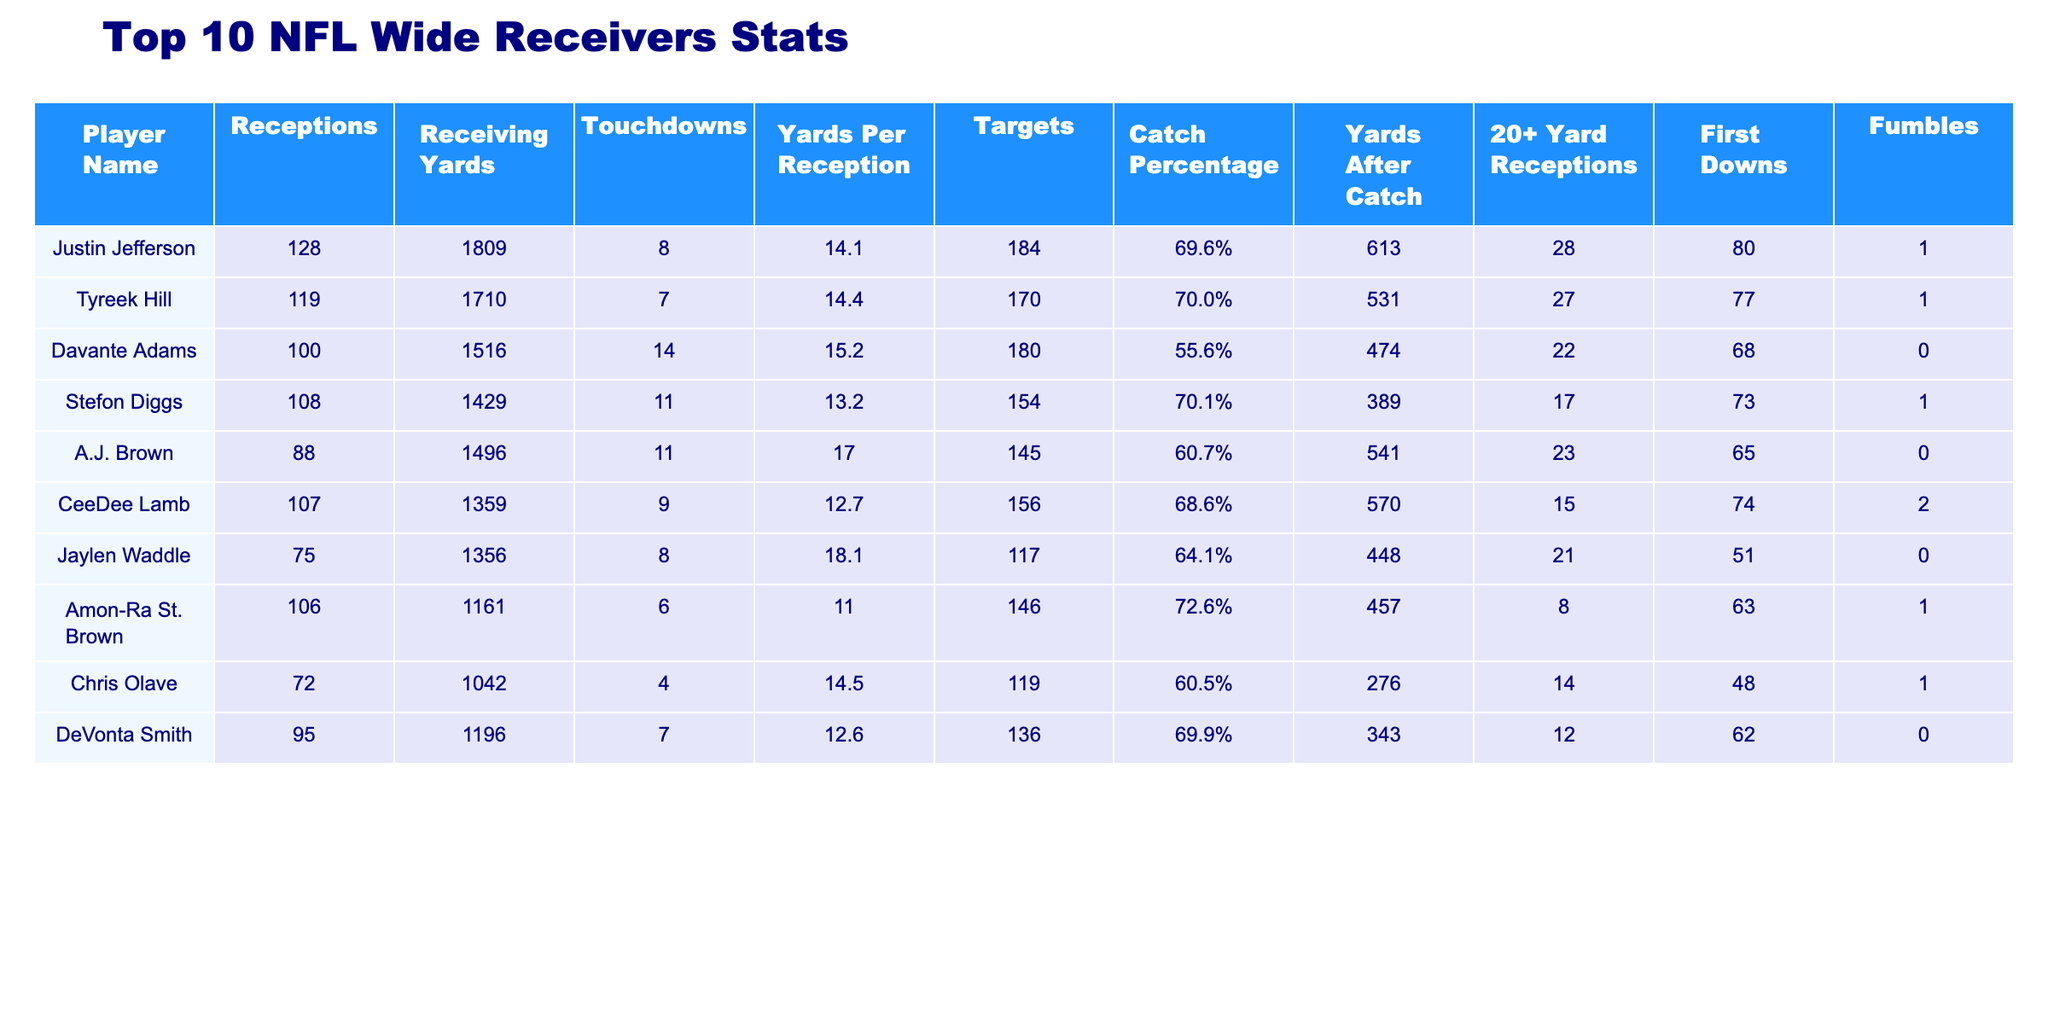What is the total number of touchdowns scored by all players in the table? To find the total number of touchdowns scored, sum the touchdowns of each player: 8 + 7 + 14 + 11 + 11 + 9 + 8 + 6 + 4 + 7 = 85.
Answer: 85 Which player has the highest receptions? Looking at the "Receptions" column, Justin Jefferson has the most receptions, with a total of 128.
Answer: Justin Jefferson What is the average yards per reception for the wide receivers? Calculate the average by summing all the yards per reception: (14.1 + 14.4 + 15.2 + 13.2 + 17.0 + 12.7 + 18.1 + 11.0 + 14.5 + 12.6) =  149.8, then divide by 10 (number of players): 149.8 / 10 = 14.98.
Answer: 14.98 True or False: Amon-Ra St. Brown had more 20+ yard receptions than DeVonta Smith. Amon-Ra St. Brown has 8 while DeVonta Smith has 12, so the statement is false.
Answer: False Which player had the lowest catch percentage? The table shows catch percentages, and Davante Adams has the lowest catch percentage at 55.6%.
Answer: Davante Adams How many players scored 10 or more touchdowns? Count the touchdowns for each player: Justin Jefferson (8), Tyreek Hill (7), Davante Adams (14), Stefon Diggs (11), A.J. Brown (11), CeeDee Lamb (9), Jaylen Waddle (8), Amon-Ra St. Brown (6), Chris Olave (4), and DeVonta Smith (7). Only Davante Adams, Stefon Diggs, and A.J. Brown scored 10 or more touchdowns, totaling 3 players.
Answer: 3 What is the total number of fumbles by the players listed? Summing the fumbles: 1 + 1 + 0 + 1 + 0 + 2 + 0 + 1 + 1 + 0 = 7.
Answer: 7 Who had the highest yards after catch? Looking at the "Yards After Catch" column, Justin Jefferson has the highest at 613 yards.
Answer: Justin Jefferson If you combine the receptions of Tyreek Hill and A.J. Brown, how many do they have together? Sum the receptions of Tyreek Hill (119) and A.J. Brown (88): 119 + 88 = 207.
Answer: 207 What percentage of catches resulted in first downs for Stefon Diggs? First, identify his receptions: 108, then divide first downs (73) by receptions and multiply by 100: (73 / 108) * 100 = 67.59%.
Answer: 67.59% Which player had the longest average yards per reception, and what is that number? From the table, A.J. Brown has the longest average yards per reception at 17.0.
Answer: A.J. Brown, 17.0 